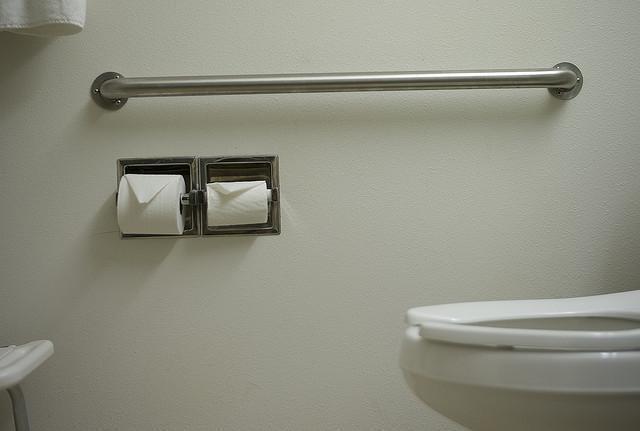How many rolls of toilet paper are there?
Give a very brief answer. 2. 